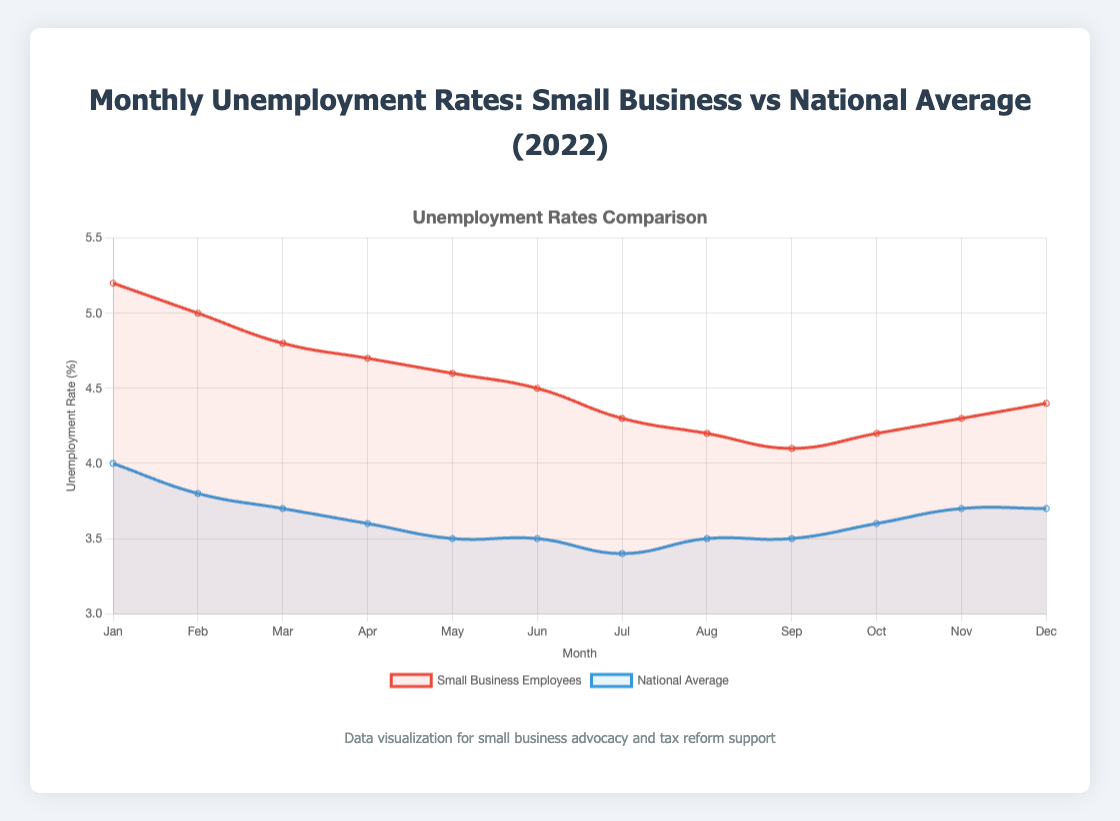What is the highest unemployment rate for small business employees in 2022? The chart shows monthly unemployment rates for small business employees. The highest rate is for January with 5.2%.
Answer: 5.2% What is the difference between the highest and lowest unemployment rates for national average in 2022? The highest national unemployment rate is in January at 4.0% and the lowest is in July at 3.4%, so the difference is 4.0% - 3.4%.
Answer: 0.6% In which months is the national average unemployment rate less than the small business employees' rate? By comparing both lines, the national average is less than the small business rate in all months listed from January to December.
Answer: Every month Is there a month where the unemployment rate for small business employees is the same as the national average? Looking at the two lines, there is no month where the unemployment rates match each other.
Answer: No What is the average unemployment rate for small business employees over the year 2022? Sum the monthly rates and divide by the number of months: (5.2 + 5.0 + 4.8 + 4.7 + 4.6 + 4.5 + 4.3 + 4.2 + 4.1 + 4.2 + 4.3 + 4.4) / 12 ≈ 4.55.
Answer: 4.55% In which month is the gap between the unemployment rate of small business employees and the national average the smallest? The smallest gap is in December 2022 with a 0.7% difference (4.4% - 3.7%).
Answer: December 2022 What trend do we see in the unemployment rate for small business employees from January to December 2022? The rate generally trends downward from January (5.2%) to the middle of the year and stabilizes around the low 4% range from July onward.
Answer: Downward Between June and July, how much did the unemployment rate change for national averages? The rate decreased from 3.5% in June to 3.4% in July, a 0.1% decrease.
Answer: 0.1% What is the visual difference in how the two unemployment rates are represented in the figure? The small business employees' rate is shown with a red line/area, while the national average rate is shown with a blue line/area.
Answer: Red and Blue lines What month shows the lowest unemployment rate for small business employees? By observing the chart, the lowest rate for small business employees occurs in September 2022 at 4.1%.
Answer: September 2022 